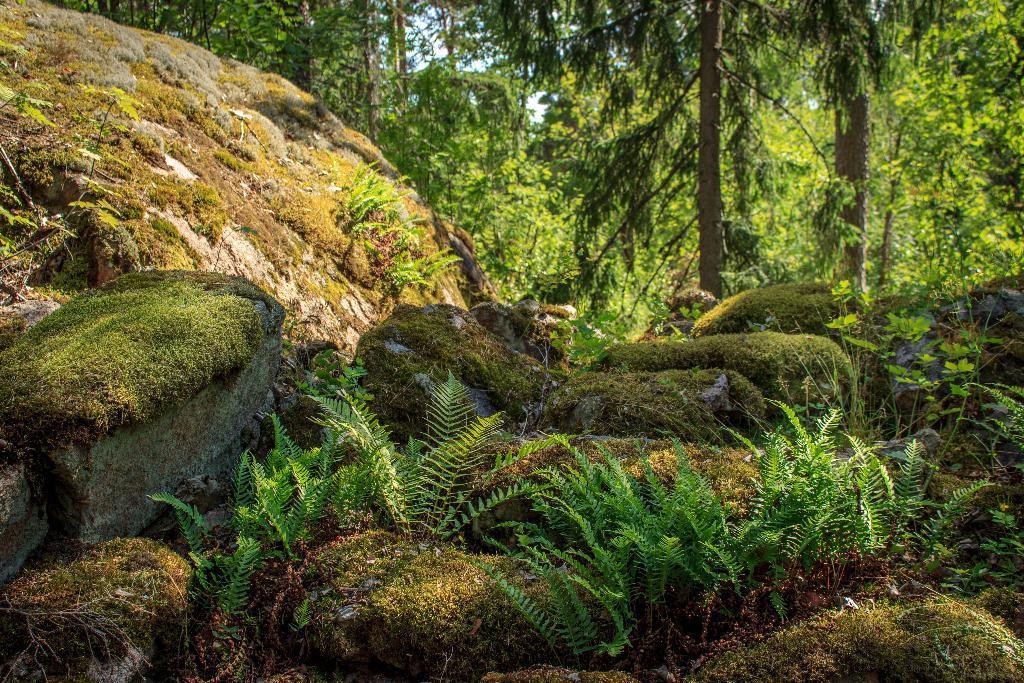In one or two sentences, can you explain what this image depicts? This image looks like it is clicked in the forest. At the bottom, there are rocks on which there is green grass. In the background, there are many trees. On the left, there is a big rock covered with grass. In the front, we can see small plants. 